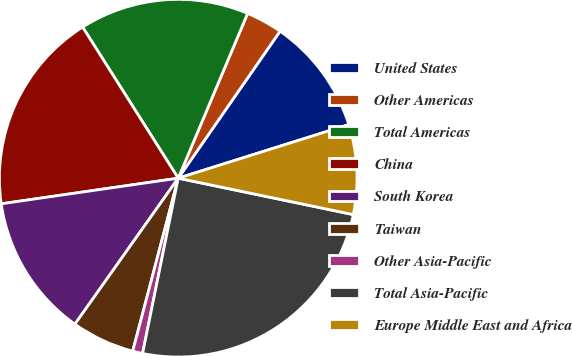Convert chart. <chart><loc_0><loc_0><loc_500><loc_500><pie_chart><fcel>United States<fcel>Other Americas<fcel>Total Americas<fcel>China<fcel>South Korea<fcel>Taiwan<fcel>Other Asia-Pacific<fcel>Total Asia-Pacific<fcel>Europe Middle East and Africa<nl><fcel>10.51%<fcel>3.3%<fcel>15.32%<fcel>18.31%<fcel>12.91%<fcel>5.71%<fcel>0.9%<fcel>24.93%<fcel>8.11%<nl></chart> 